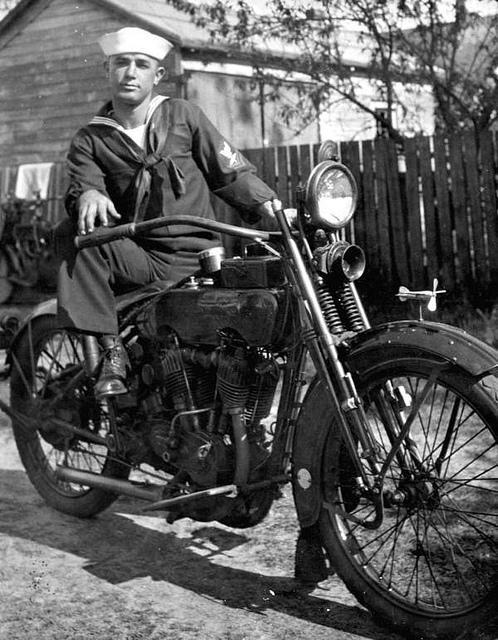How many birds are standing on the boat?
Give a very brief answer. 0. 